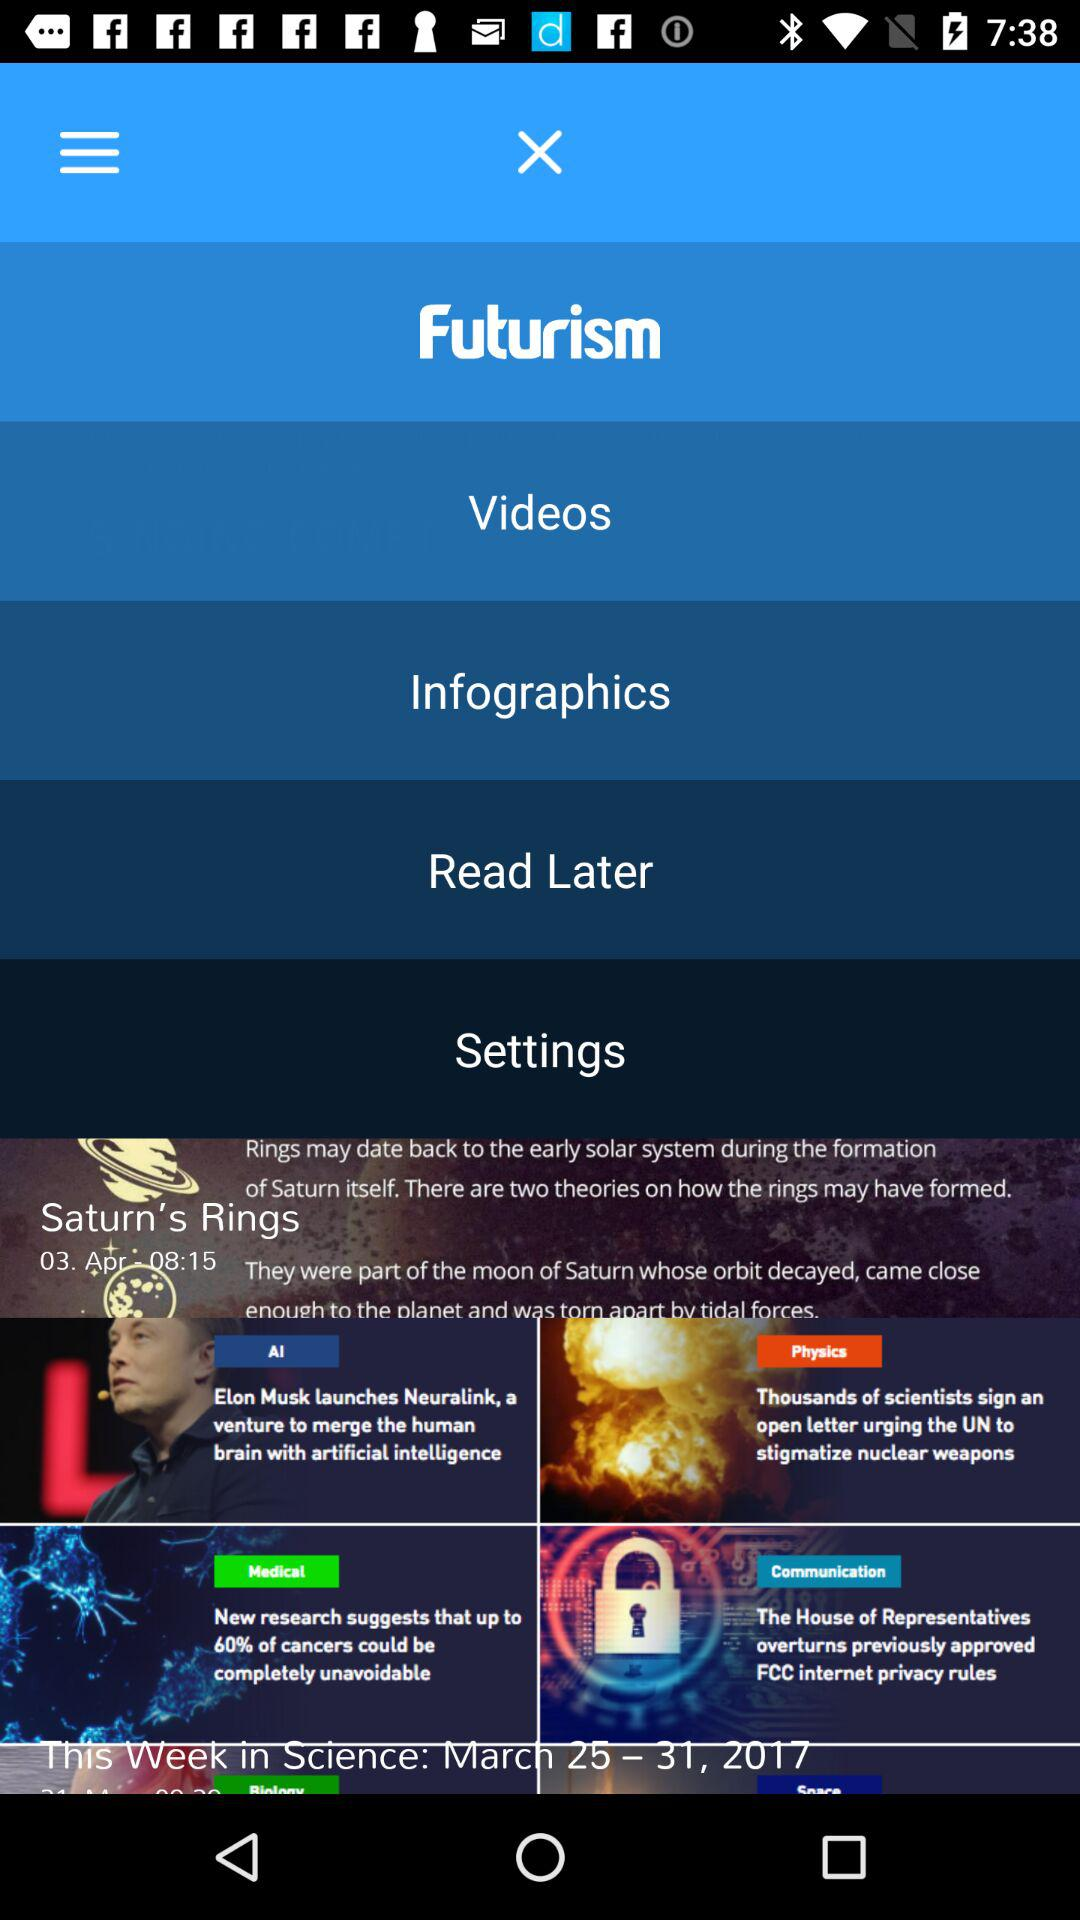At what date and time Saturn rings are read?
When the provided information is insufficient, respond with <no answer>. <no answer> 